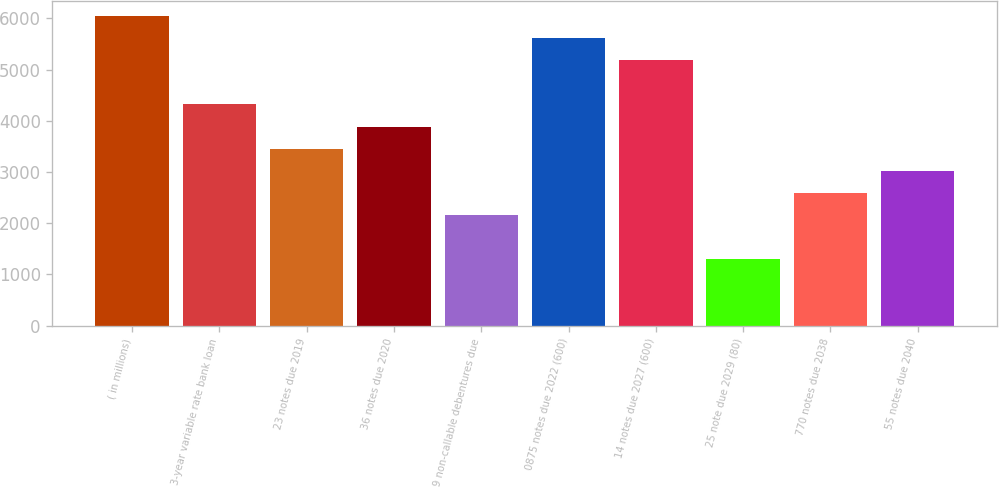Convert chart. <chart><loc_0><loc_0><loc_500><loc_500><bar_chart><fcel>( in millions)<fcel>3-year variable rate bank loan<fcel>23 notes due 2019<fcel>36 notes due 2020<fcel>9 non-callable debentures due<fcel>0875 notes due 2022 (600)<fcel>14 notes due 2027 (600)<fcel>25 note due 2029 (80)<fcel>770 notes due 2038<fcel>55 notes due 2040<nl><fcel>6042.6<fcel>4317<fcel>3454.2<fcel>3885.6<fcel>2160<fcel>5611.2<fcel>5179.8<fcel>1297.2<fcel>2591.4<fcel>3022.8<nl></chart> 